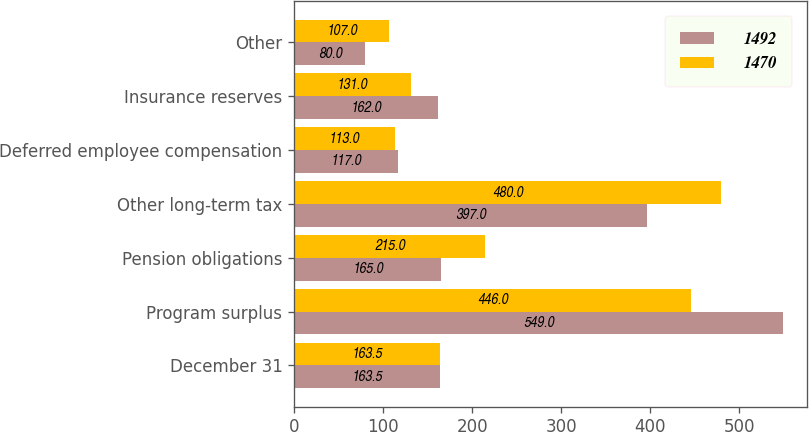Convert chart to OTSL. <chart><loc_0><loc_0><loc_500><loc_500><stacked_bar_chart><ecel><fcel>December 31<fcel>Program surplus<fcel>Pension obligations<fcel>Other long-term tax<fcel>Deferred employee compensation<fcel>Insurance reserves<fcel>Other<nl><fcel>1492<fcel>163.5<fcel>549<fcel>165<fcel>397<fcel>117<fcel>162<fcel>80<nl><fcel>1470<fcel>163.5<fcel>446<fcel>215<fcel>480<fcel>113<fcel>131<fcel>107<nl></chart> 